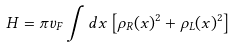<formula> <loc_0><loc_0><loc_500><loc_500>H = \pi v _ { F } \int d x \left [ \rho _ { R } ( x ) ^ { 2 } + \rho _ { L } ( x ) ^ { 2 } \right ]</formula> 